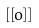<formula> <loc_0><loc_0><loc_500><loc_500>\left [ \left [ o \right ] \right ]</formula> 